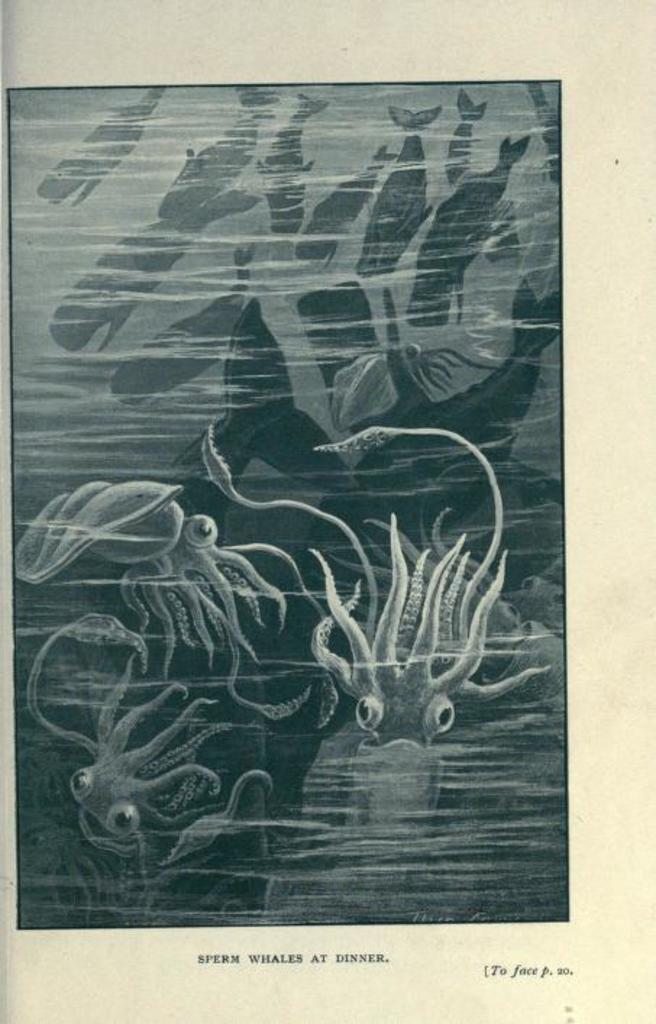Please provide a concise description of this image. In this image I can see depiction picture of aquatic animals. I can also see something is written on the bottom side of this image. 